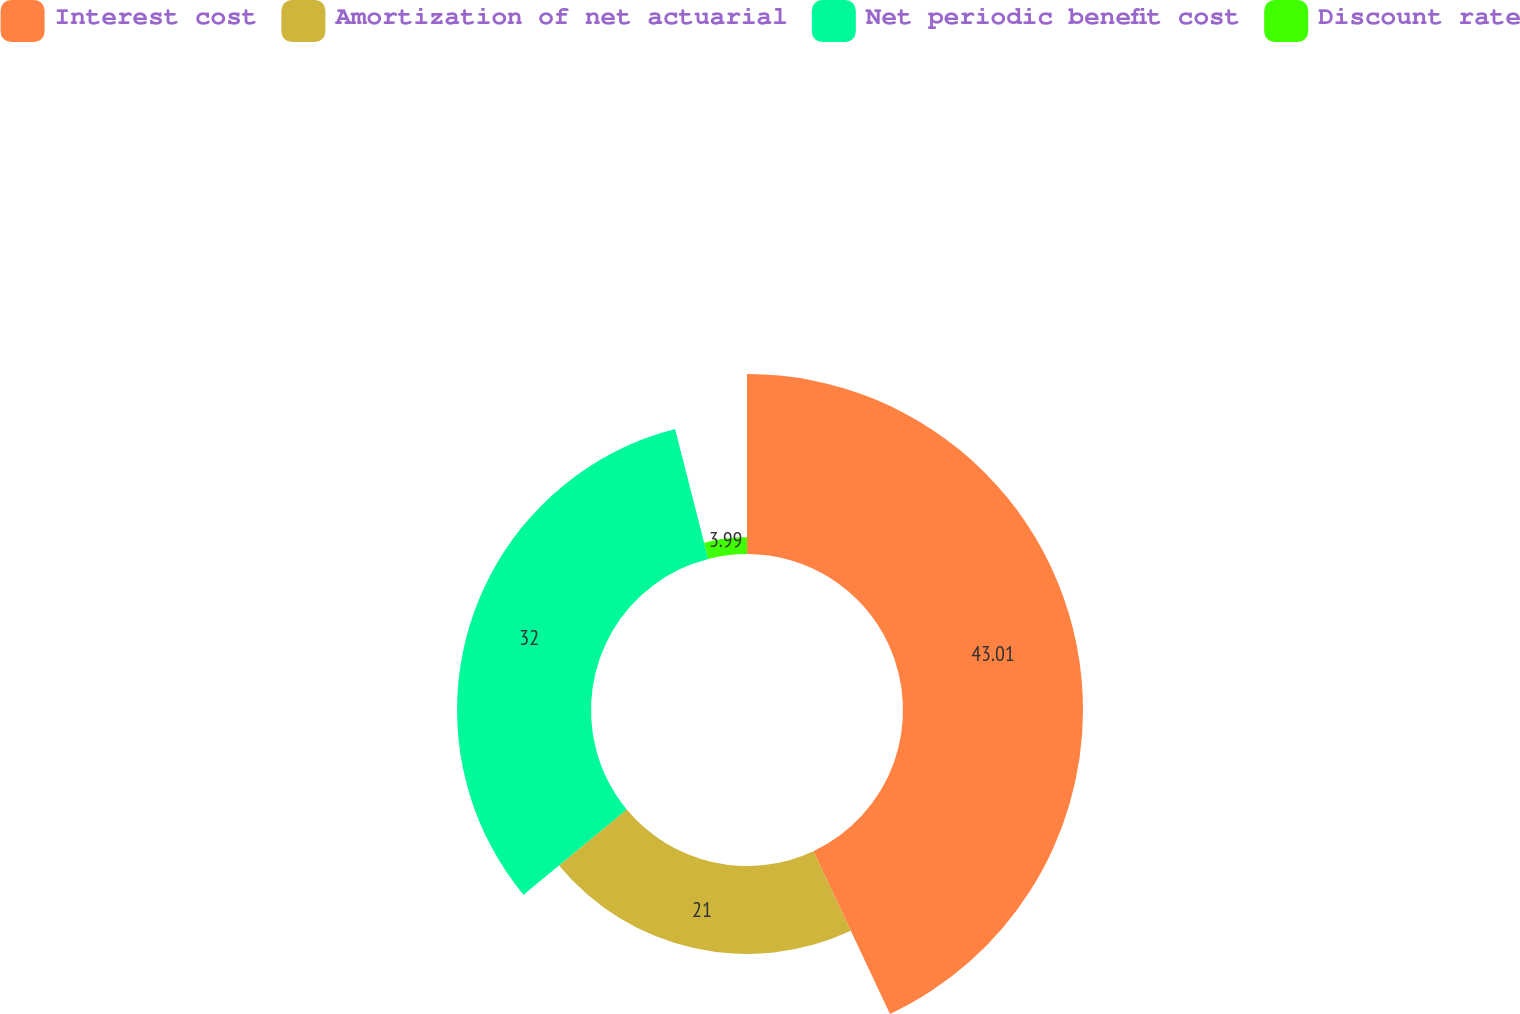<chart> <loc_0><loc_0><loc_500><loc_500><pie_chart><fcel>Interest cost<fcel>Amortization of net actuarial<fcel>Net periodic benefit cost<fcel>Discount rate<nl><fcel>43.0%<fcel>21.0%<fcel>32.0%<fcel>3.99%<nl></chart> 